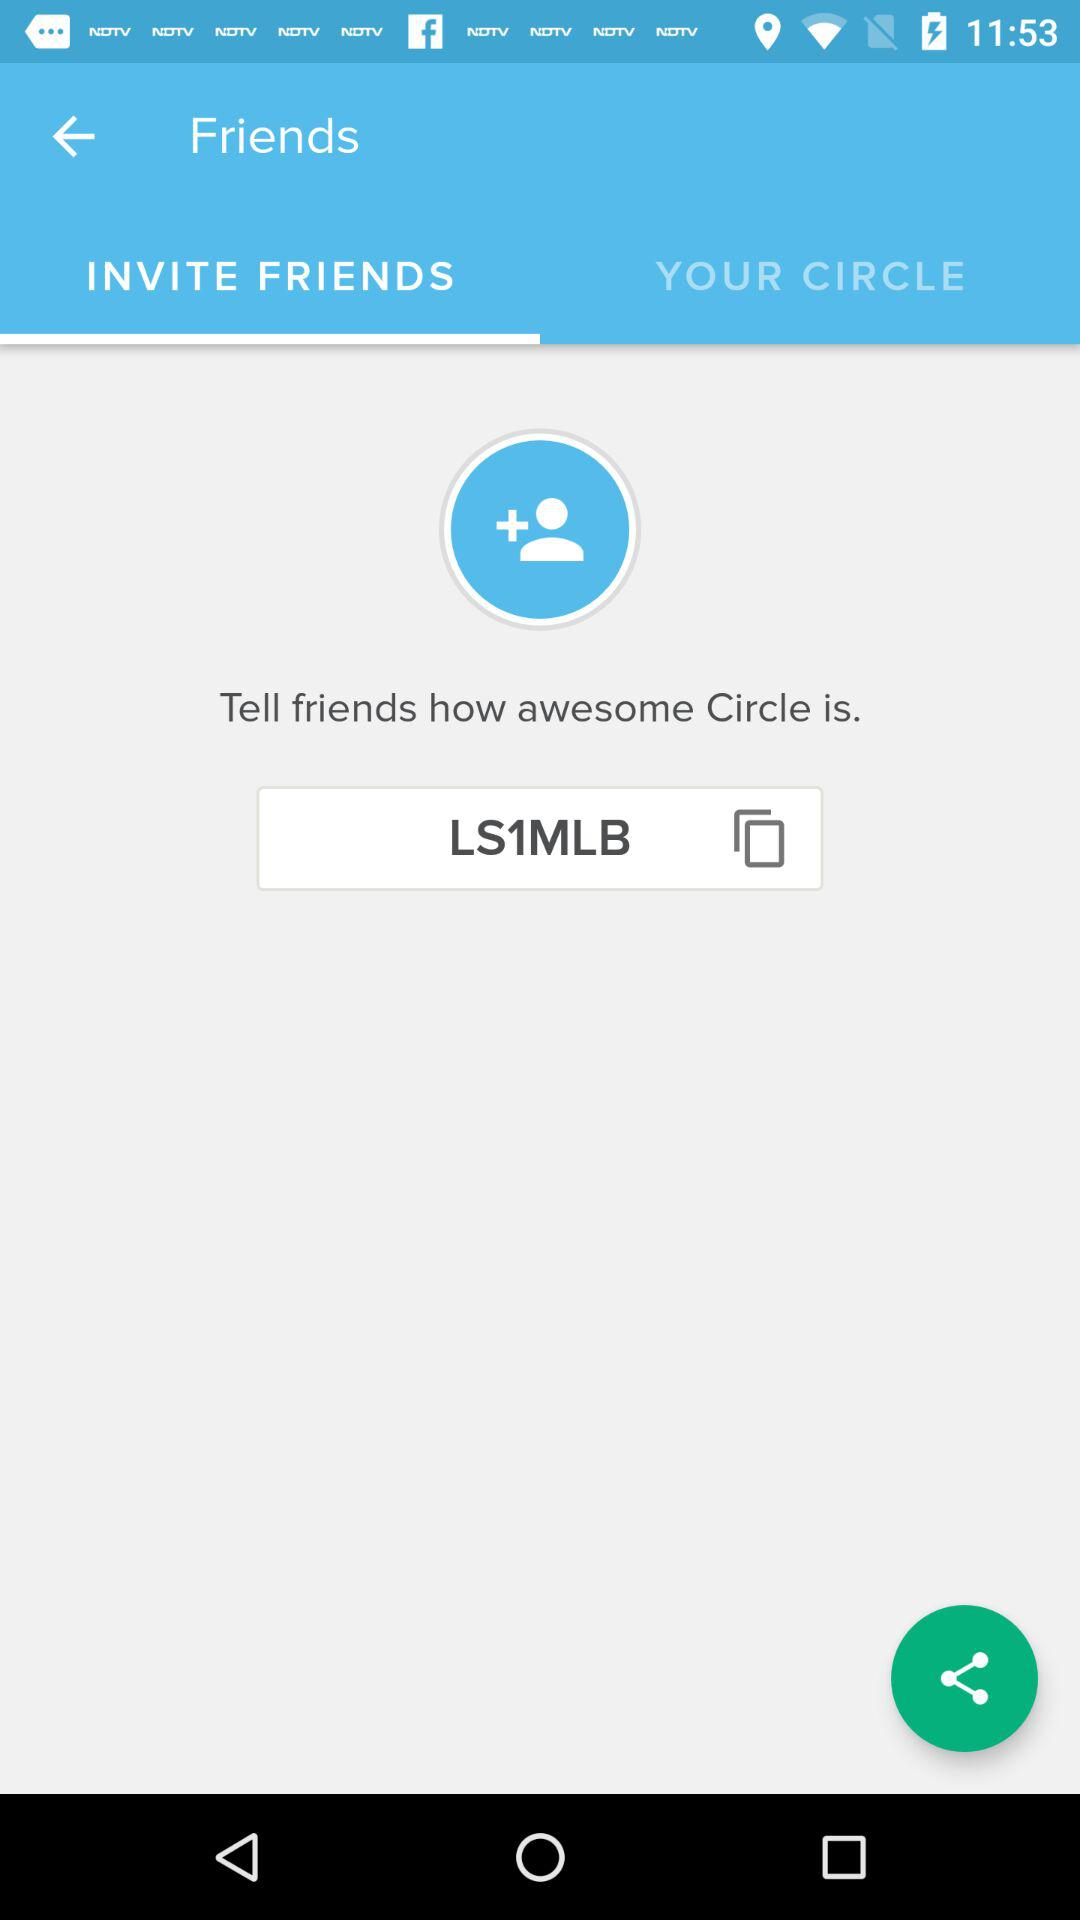What is the referral code? The referral code is "LS1MLB". 